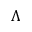Convert formula to latex. <formula><loc_0><loc_0><loc_500><loc_500>\Lambda</formula> 